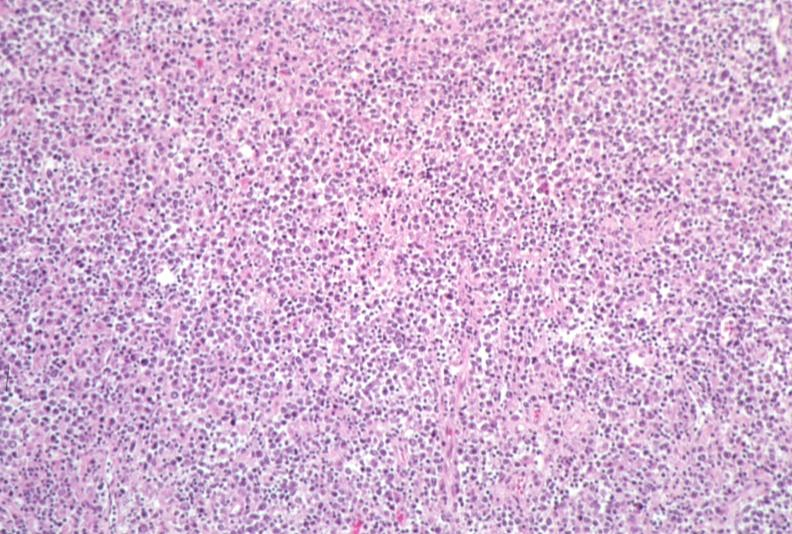what does this image show?
Answer the question using a single word or phrase. Lymph node 